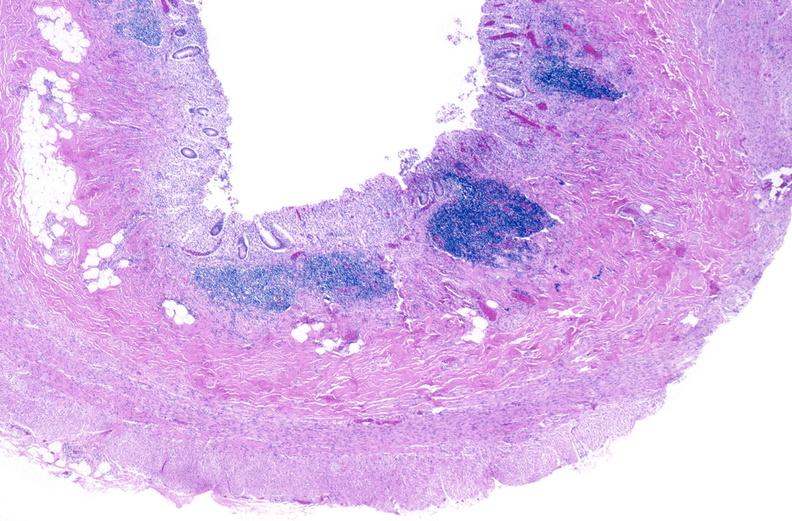s gastrointestinal present?
Answer the question using a single word or phrase. Yes 